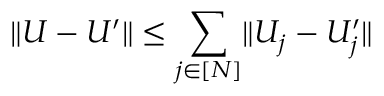<formula> <loc_0><loc_0><loc_500><loc_500>\| U - U ^ { \prime } \| \leq \sum _ { j \in [ N ] } \| U _ { j } - U _ { j } ^ { \prime } \|</formula> 